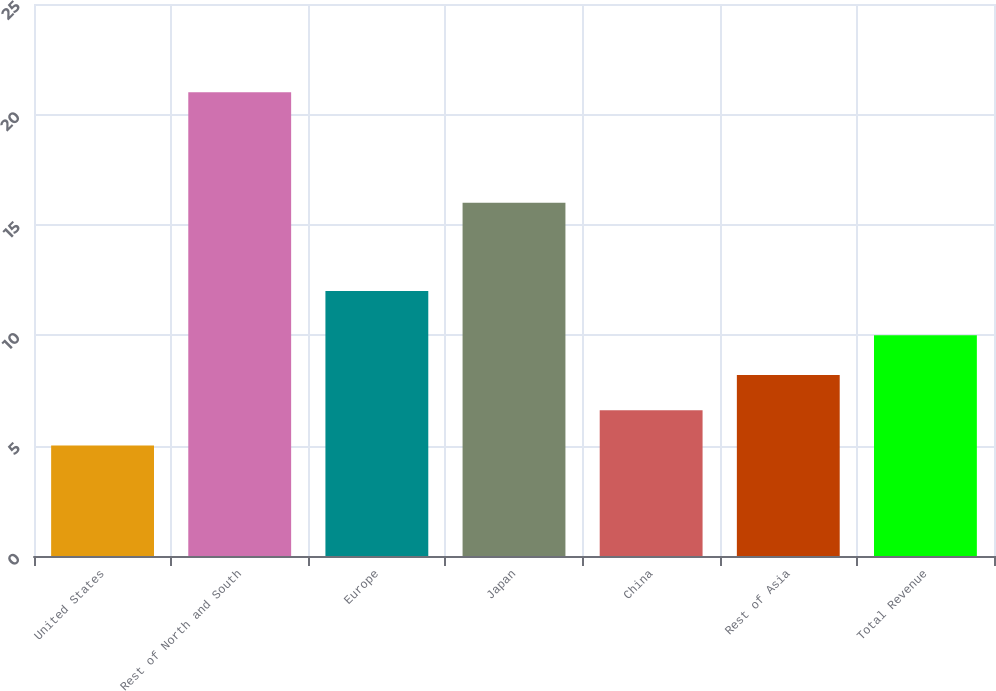<chart> <loc_0><loc_0><loc_500><loc_500><bar_chart><fcel>United States<fcel>Rest of North and South<fcel>Europe<fcel>Japan<fcel>China<fcel>Rest of Asia<fcel>Total Revenue<nl><fcel>5<fcel>21<fcel>12<fcel>16<fcel>6.6<fcel>8.2<fcel>10<nl></chart> 